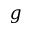Convert formula to latex. <formula><loc_0><loc_0><loc_500><loc_500>g</formula> 